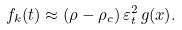<formula> <loc_0><loc_0><loc_500><loc_500>f _ { k } ( t ) \approx ( \rho - \rho _ { c } ) \, \varepsilon _ { t } ^ { 2 } \, g ( x ) .</formula> 